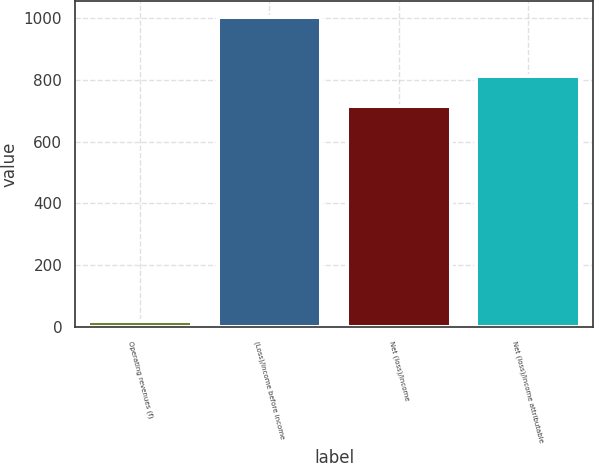<chart> <loc_0><loc_0><loc_500><loc_500><bar_chart><fcel>Operating revenues (f)<fcel>(Loss)/income before income<fcel>Net (loss)/income<fcel>Net (loss)/income attributable<nl><fcel>19<fcel>1005<fcel>715<fcel>813.6<nl></chart> 